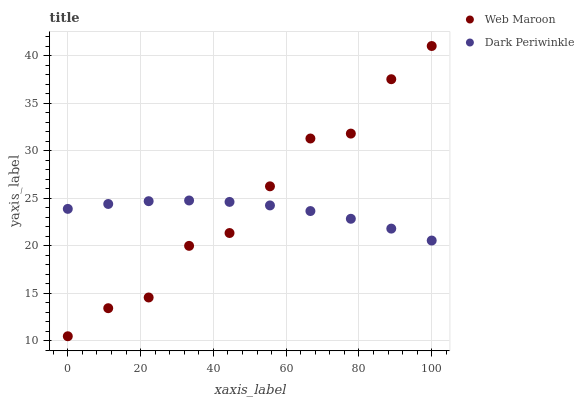Does Dark Periwinkle have the minimum area under the curve?
Answer yes or no. Yes. Does Web Maroon have the maximum area under the curve?
Answer yes or no. Yes. Does Dark Periwinkle have the maximum area under the curve?
Answer yes or no. No. Is Dark Periwinkle the smoothest?
Answer yes or no. Yes. Is Web Maroon the roughest?
Answer yes or no. Yes. Is Dark Periwinkle the roughest?
Answer yes or no. No. Does Web Maroon have the lowest value?
Answer yes or no. Yes. Does Dark Periwinkle have the lowest value?
Answer yes or no. No. Does Web Maroon have the highest value?
Answer yes or no. Yes. Does Dark Periwinkle have the highest value?
Answer yes or no. No. Does Web Maroon intersect Dark Periwinkle?
Answer yes or no. Yes. Is Web Maroon less than Dark Periwinkle?
Answer yes or no. No. Is Web Maroon greater than Dark Periwinkle?
Answer yes or no. No. 